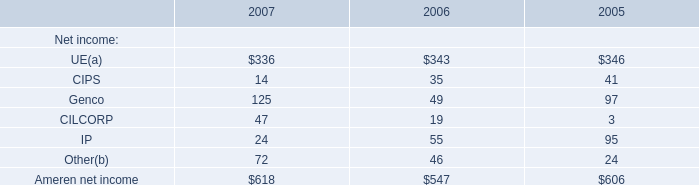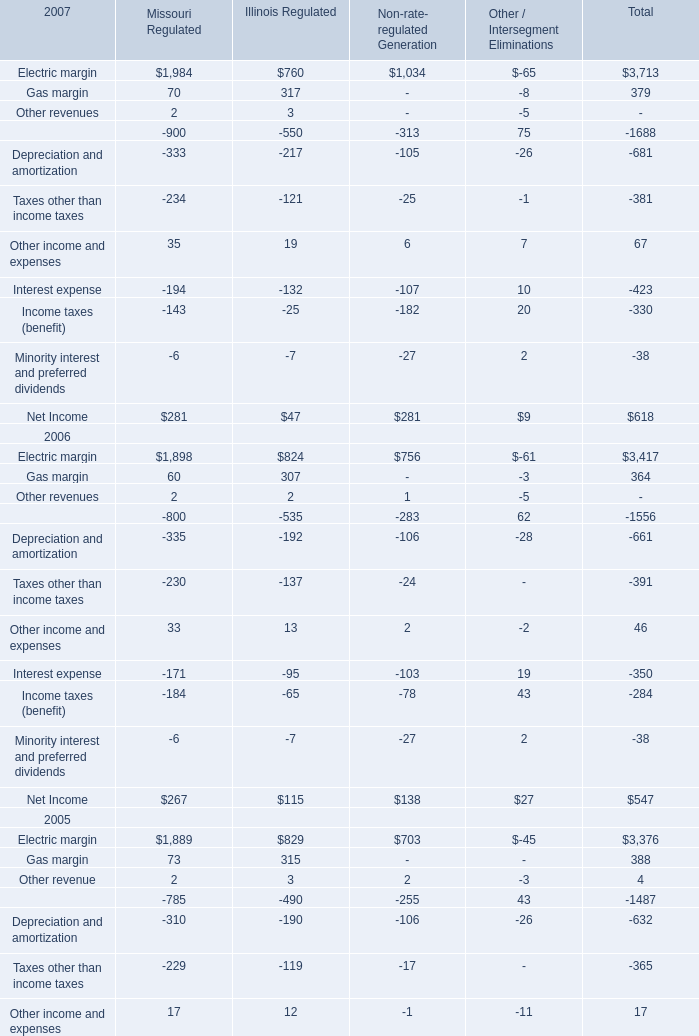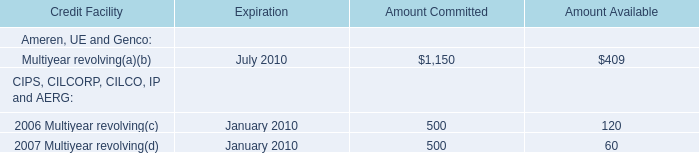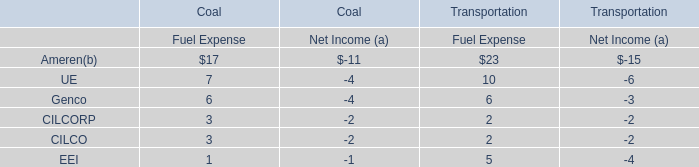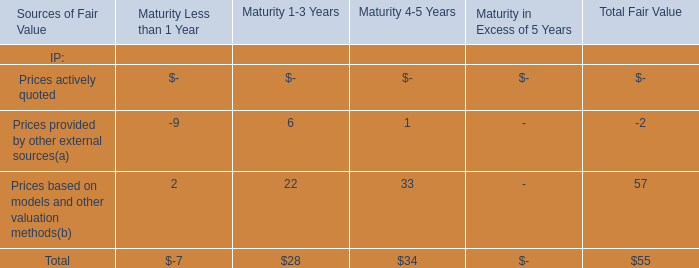What's the average of the Other income and expenses in the year where Electric margin of Total is positive? (in dollars) 
Computations: ((((35 + 19) + 6) + 7) / 4)
Answer: 16.75. 